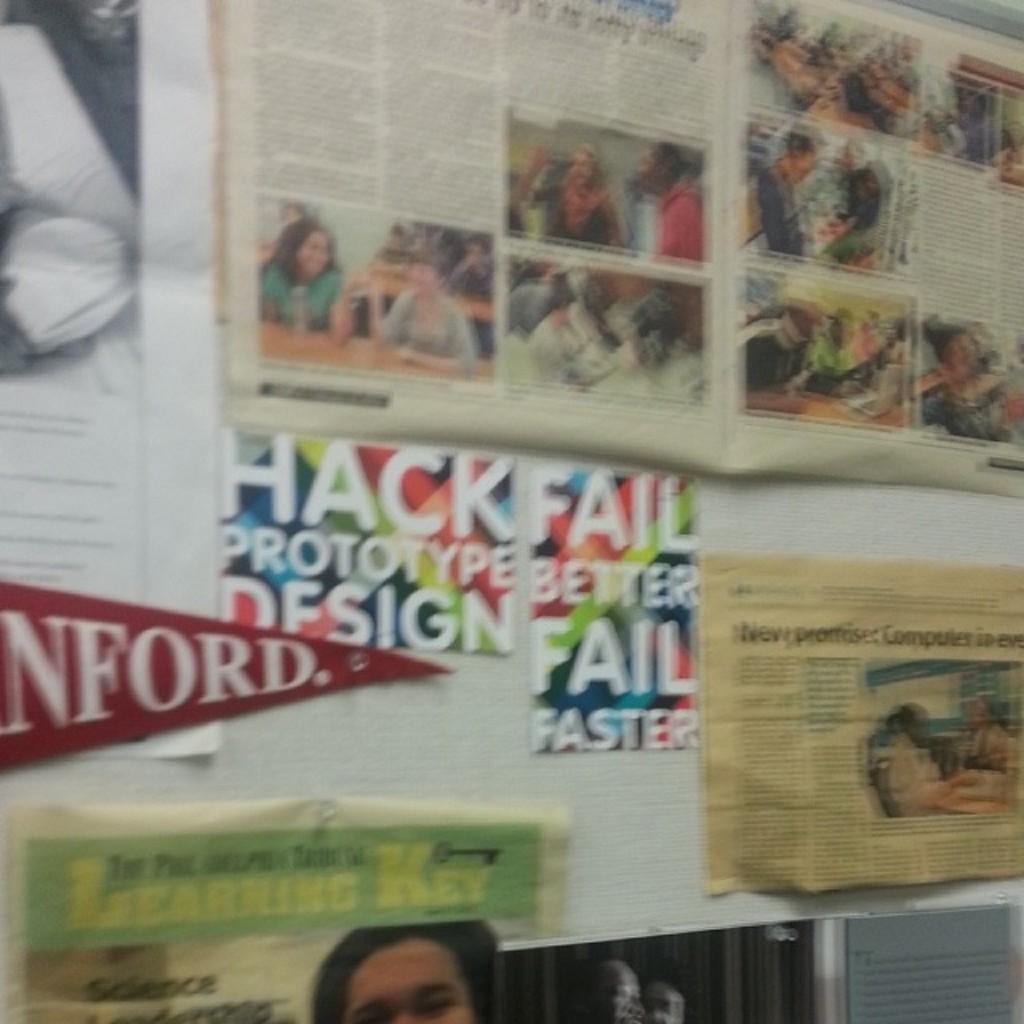What is hack prototype design?
Offer a terse response. Unanswerable. Is this place in standford?
Keep it short and to the point. Yes. 